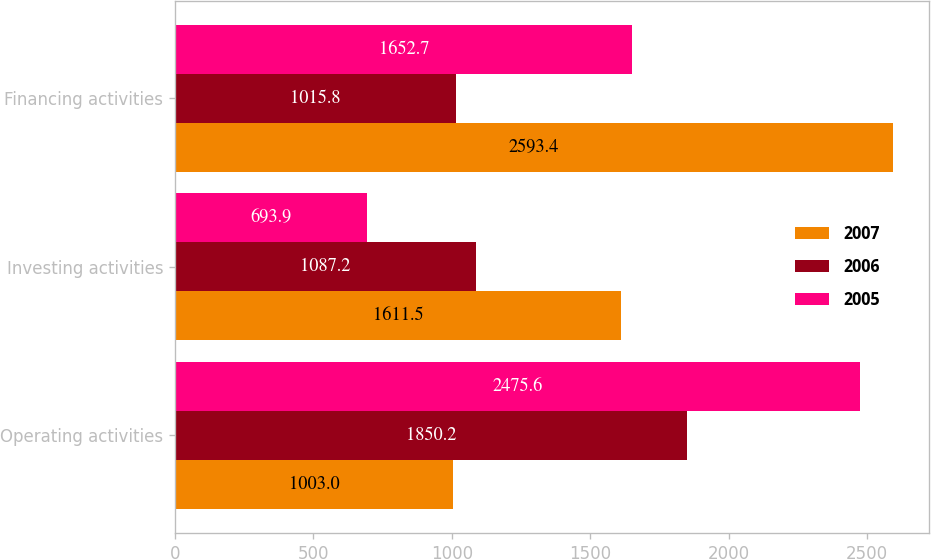<chart> <loc_0><loc_0><loc_500><loc_500><stacked_bar_chart><ecel><fcel>Operating activities<fcel>Investing activities<fcel>Financing activities<nl><fcel>2007<fcel>1003<fcel>1611.5<fcel>2593.4<nl><fcel>2006<fcel>1850.2<fcel>1087.2<fcel>1015.8<nl><fcel>2005<fcel>2475.6<fcel>693.9<fcel>1652.7<nl></chart> 